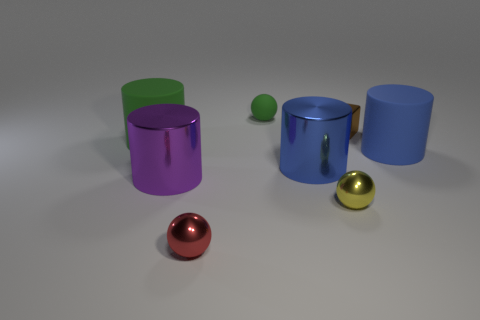Subtract all tiny metal balls. How many balls are left? 1 Subtract all blue cylinders. How many cylinders are left? 2 Add 1 yellow metallic spheres. How many objects exist? 9 Subtract 2 cylinders. How many cylinders are left? 2 Add 6 blue metal objects. How many blue metal objects are left? 7 Add 3 red spheres. How many red spheres exist? 4 Subtract 0 blue blocks. How many objects are left? 8 Subtract all balls. How many objects are left? 5 Subtract all brown cylinders. Subtract all brown balls. How many cylinders are left? 4 Subtract all green spheres. How many green cylinders are left? 1 